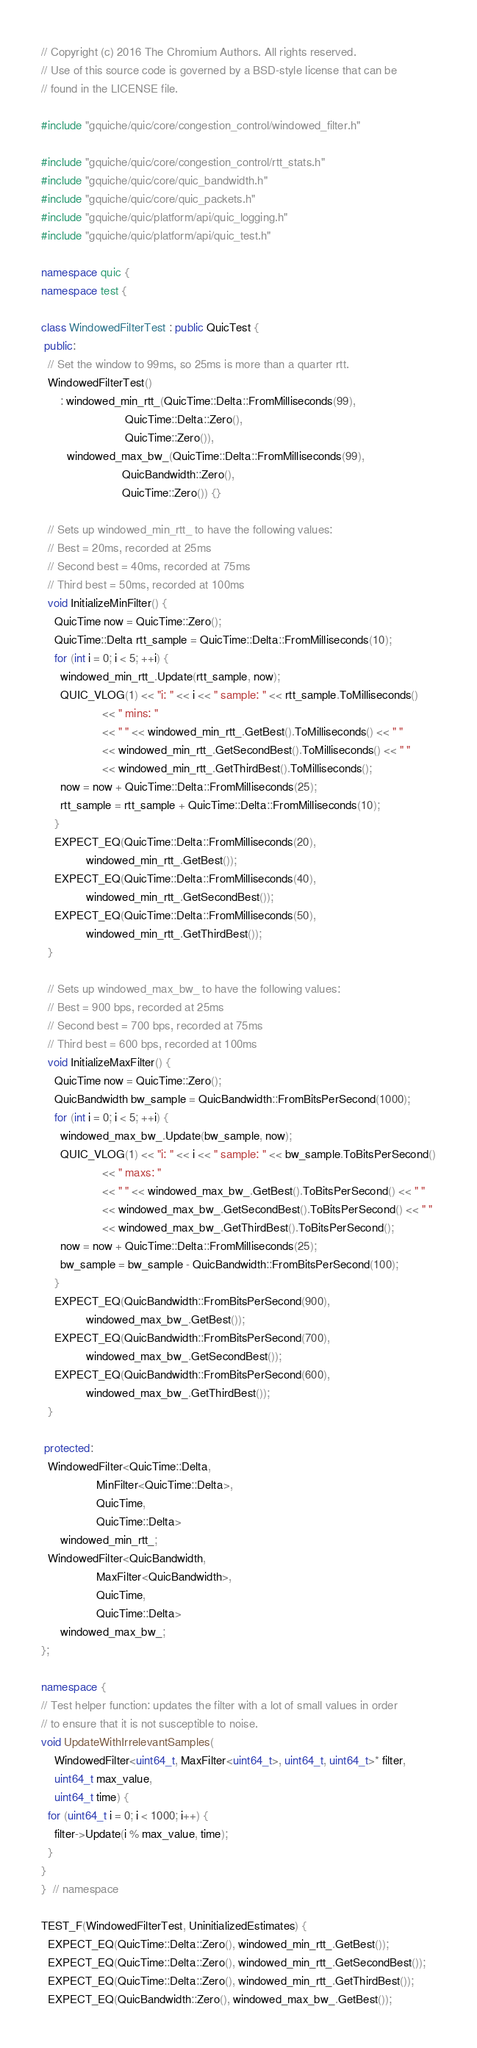Convert code to text. <code><loc_0><loc_0><loc_500><loc_500><_C++_>// Copyright (c) 2016 The Chromium Authors. All rights reserved.
// Use of this source code is governed by a BSD-style license that can be
// found in the LICENSE file.

#include "gquiche/quic/core/congestion_control/windowed_filter.h"

#include "gquiche/quic/core/congestion_control/rtt_stats.h"
#include "gquiche/quic/core/quic_bandwidth.h"
#include "gquiche/quic/core/quic_packets.h"
#include "gquiche/quic/platform/api/quic_logging.h"
#include "gquiche/quic/platform/api/quic_test.h"

namespace quic {
namespace test {

class WindowedFilterTest : public QuicTest {
 public:
  // Set the window to 99ms, so 25ms is more than a quarter rtt.
  WindowedFilterTest()
      : windowed_min_rtt_(QuicTime::Delta::FromMilliseconds(99),
                          QuicTime::Delta::Zero(),
                          QuicTime::Zero()),
        windowed_max_bw_(QuicTime::Delta::FromMilliseconds(99),
                         QuicBandwidth::Zero(),
                         QuicTime::Zero()) {}

  // Sets up windowed_min_rtt_ to have the following values:
  // Best = 20ms, recorded at 25ms
  // Second best = 40ms, recorded at 75ms
  // Third best = 50ms, recorded at 100ms
  void InitializeMinFilter() {
    QuicTime now = QuicTime::Zero();
    QuicTime::Delta rtt_sample = QuicTime::Delta::FromMilliseconds(10);
    for (int i = 0; i < 5; ++i) {
      windowed_min_rtt_.Update(rtt_sample, now);
      QUIC_VLOG(1) << "i: " << i << " sample: " << rtt_sample.ToMilliseconds()
                   << " mins: "
                   << " " << windowed_min_rtt_.GetBest().ToMilliseconds() << " "
                   << windowed_min_rtt_.GetSecondBest().ToMilliseconds() << " "
                   << windowed_min_rtt_.GetThirdBest().ToMilliseconds();
      now = now + QuicTime::Delta::FromMilliseconds(25);
      rtt_sample = rtt_sample + QuicTime::Delta::FromMilliseconds(10);
    }
    EXPECT_EQ(QuicTime::Delta::FromMilliseconds(20),
              windowed_min_rtt_.GetBest());
    EXPECT_EQ(QuicTime::Delta::FromMilliseconds(40),
              windowed_min_rtt_.GetSecondBest());
    EXPECT_EQ(QuicTime::Delta::FromMilliseconds(50),
              windowed_min_rtt_.GetThirdBest());
  }

  // Sets up windowed_max_bw_ to have the following values:
  // Best = 900 bps, recorded at 25ms
  // Second best = 700 bps, recorded at 75ms
  // Third best = 600 bps, recorded at 100ms
  void InitializeMaxFilter() {
    QuicTime now = QuicTime::Zero();
    QuicBandwidth bw_sample = QuicBandwidth::FromBitsPerSecond(1000);
    for (int i = 0; i < 5; ++i) {
      windowed_max_bw_.Update(bw_sample, now);
      QUIC_VLOG(1) << "i: " << i << " sample: " << bw_sample.ToBitsPerSecond()
                   << " maxs: "
                   << " " << windowed_max_bw_.GetBest().ToBitsPerSecond() << " "
                   << windowed_max_bw_.GetSecondBest().ToBitsPerSecond() << " "
                   << windowed_max_bw_.GetThirdBest().ToBitsPerSecond();
      now = now + QuicTime::Delta::FromMilliseconds(25);
      bw_sample = bw_sample - QuicBandwidth::FromBitsPerSecond(100);
    }
    EXPECT_EQ(QuicBandwidth::FromBitsPerSecond(900),
              windowed_max_bw_.GetBest());
    EXPECT_EQ(QuicBandwidth::FromBitsPerSecond(700),
              windowed_max_bw_.GetSecondBest());
    EXPECT_EQ(QuicBandwidth::FromBitsPerSecond(600),
              windowed_max_bw_.GetThirdBest());
  }

 protected:
  WindowedFilter<QuicTime::Delta,
                 MinFilter<QuicTime::Delta>,
                 QuicTime,
                 QuicTime::Delta>
      windowed_min_rtt_;
  WindowedFilter<QuicBandwidth,
                 MaxFilter<QuicBandwidth>,
                 QuicTime,
                 QuicTime::Delta>
      windowed_max_bw_;
};

namespace {
// Test helper function: updates the filter with a lot of small values in order
// to ensure that it is not susceptible to noise.
void UpdateWithIrrelevantSamples(
    WindowedFilter<uint64_t, MaxFilter<uint64_t>, uint64_t, uint64_t>* filter,
    uint64_t max_value,
    uint64_t time) {
  for (uint64_t i = 0; i < 1000; i++) {
    filter->Update(i % max_value, time);
  }
}
}  // namespace

TEST_F(WindowedFilterTest, UninitializedEstimates) {
  EXPECT_EQ(QuicTime::Delta::Zero(), windowed_min_rtt_.GetBest());
  EXPECT_EQ(QuicTime::Delta::Zero(), windowed_min_rtt_.GetSecondBest());
  EXPECT_EQ(QuicTime::Delta::Zero(), windowed_min_rtt_.GetThirdBest());
  EXPECT_EQ(QuicBandwidth::Zero(), windowed_max_bw_.GetBest());</code> 